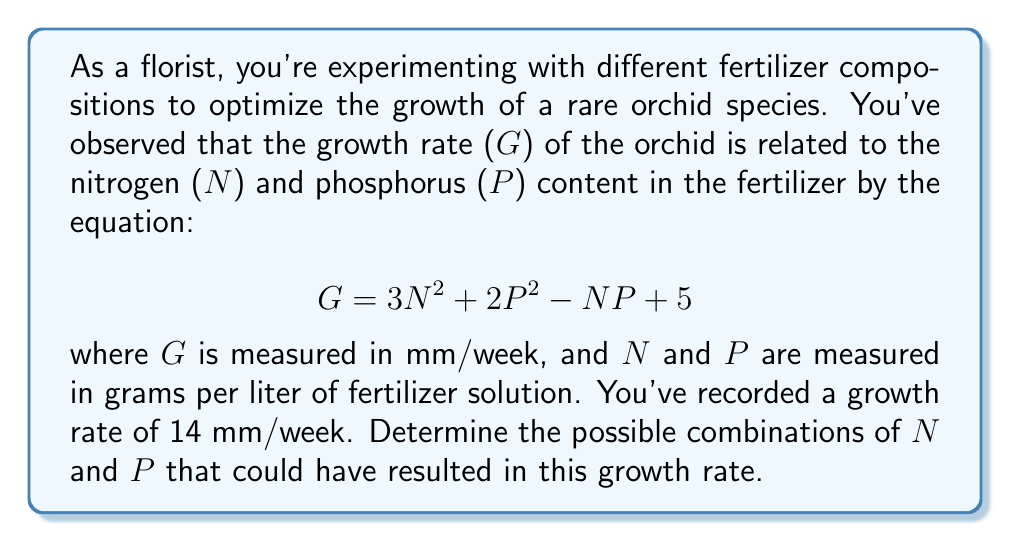Help me with this question. To solve this inverse problem, we need to find the combinations of N and P that satisfy the given equation when G = 14. Let's approach this step-by-step:

1) Substitute the known value of G into the equation:
   $$14 = 3N^2 + 2P^2 - NP + 5$$

2) Rearrange the equation:
   $$3N^2 + 2P^2 - NP - 9 = 0$$

3) This is a two-variable quadratic equation. It represents a curve in the N-P plane. To find the possible combinations, we can treat this as an implicit function and solve for P in terms of N:

   $$2P^2 - NP + (3N^2 - 9) = 0$$

4) This is a quadratic in P. We can solve it using the quadratic formula:

   $$P = \frac{N \pm \sqrt{N^2 - 4(2)(3N^2 - 9)}}{2(2)}$$

5) Simplify:
   $$P = \frac{N \pm \sqrt{N^2 - 24N^2 + 72}}{4}$$
   $$P = \frac{N \pm \sqrt{-23N^2 + 72}}{4}$$

6) For real solutions to exist, the discriminant must be non-negative:
   $$-23N^2 + 72 \geq 0$$
   $$23N^2 \leq 72$$
   $$N^2 \leq \frac{72}{23}$$
   $$-\sqrt{\frac{72}{23}} \leq N \leq \sqrt{\frac{72}{23}}$$

7) Therefore, N is bounded between approximately -1.77 and 1.77.

8) For any value of N within this range, there will be two corresponding values of P (unless N is exactly at the bounds, in which case there will be one P value).

The solution is thus a set of points (N, P) that satisfy the original equation and the derived constraints.
Answer: $N \in [-\sqrt{\frac{72}{23}}, \sqrt{\frac{72}{23}}]$, $P = \frac{N \pm \sqrt{-23N^2 + 72}}{4}$ 